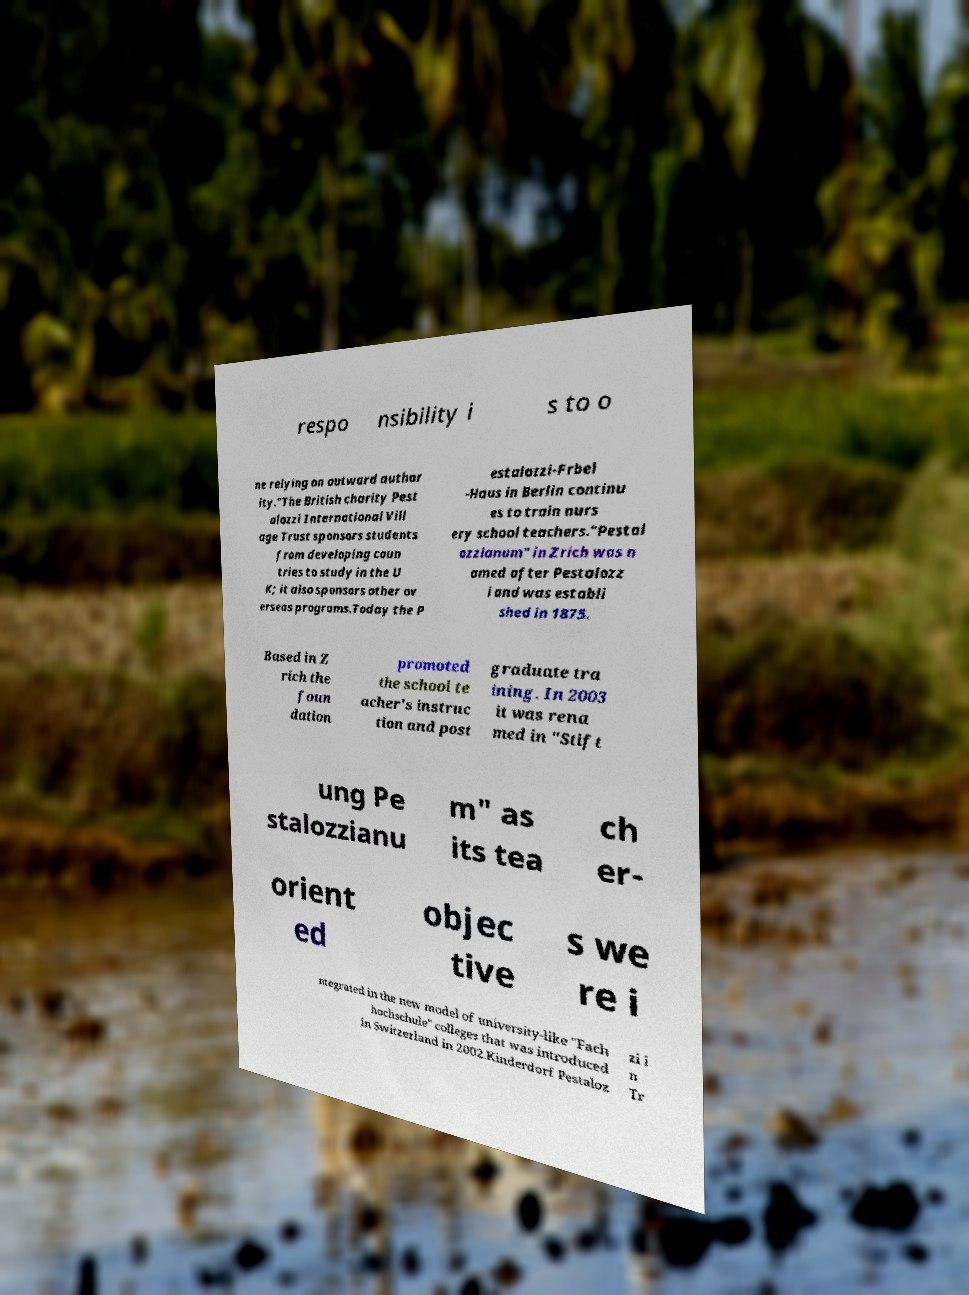I need the written content from this picture converted into text. Can you do that? respo nsibility i s to o ne relying on outward author ity."The British charity Pest alozzi International Vill age Trust sponsors students from developing coun tries to study in the U K; it also sponsors other ov erseas programs.Today the P estalozzi-Frbel -Haus in Berlin continu es to train nurs ery school teachers."Pestal ozzianum" in Zrich was n amed after Pestalozz i and was establi shed in 1875. Based in Z rich the foun dation promoted the school te acher's instruc tion and post graduate tra ining. In 2003 it was rena med in "Stift ung Pe stalozzianu m" as its tea ch er- orient ed objec tive s we re i ntegrated in the new model of university-like "Fach hochschule" colleges that was introduced in Switzerland in 2002.Kinderdorf Pestaloz zi i n Tr 